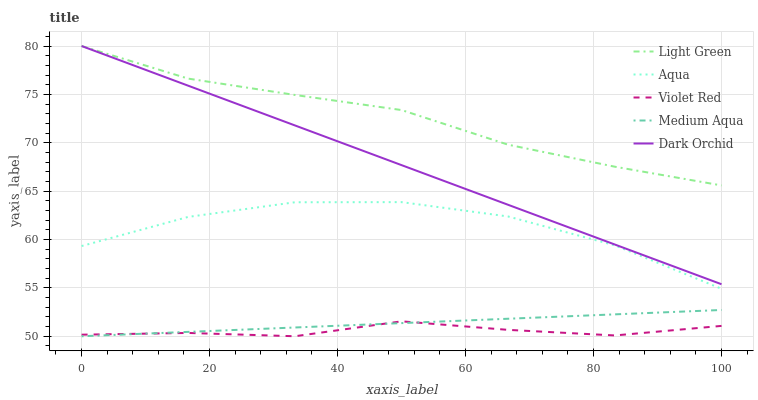Does Violet Red have the minimum area under the curve?
Answer yes or no. Yes. Does Light Green have the maximum area under the curve?
Answer yes or no. Yes. Does Aqua have the minimum area under the curve?
Answer yes or no. No. Does Aqua have the maximum area under the curve?
Answer yes or no. No. Is Medium Aqua the smoothest?
Answer yes or no. Yes. Is Aqua the roughest?
Answer yes or no. Yes. Is Violet Red the smoothest?
Answer yes or no. No. Is Violet Red the roughest?
Answer yes or no. No. Does Medium Aqua have the lowest value?
Answer yes or no. Yes. Does Aqua have the lowest value?
Answer yes or no. No. Does Light Green have the highest value?
Answer yes or no. Yes. Does Aqua have the highest value?
Answer yes or no. No. Is Medium Aqua less than Aqua?
Answer yes or no. Yes. Is Light Green greater than Medium Aqua?
Answer yes or no. Yes. Does Dark Orchid intersect Light Green?
Answer yes or no. Yes. Is Dark Orchid less than Light Green?
Answer yes or no. No. Is Dark Orchid greater than Light Green?
Answer yes or no. No. Does Medium Aqua intersect Aqua?
Answer yes or no. No. 